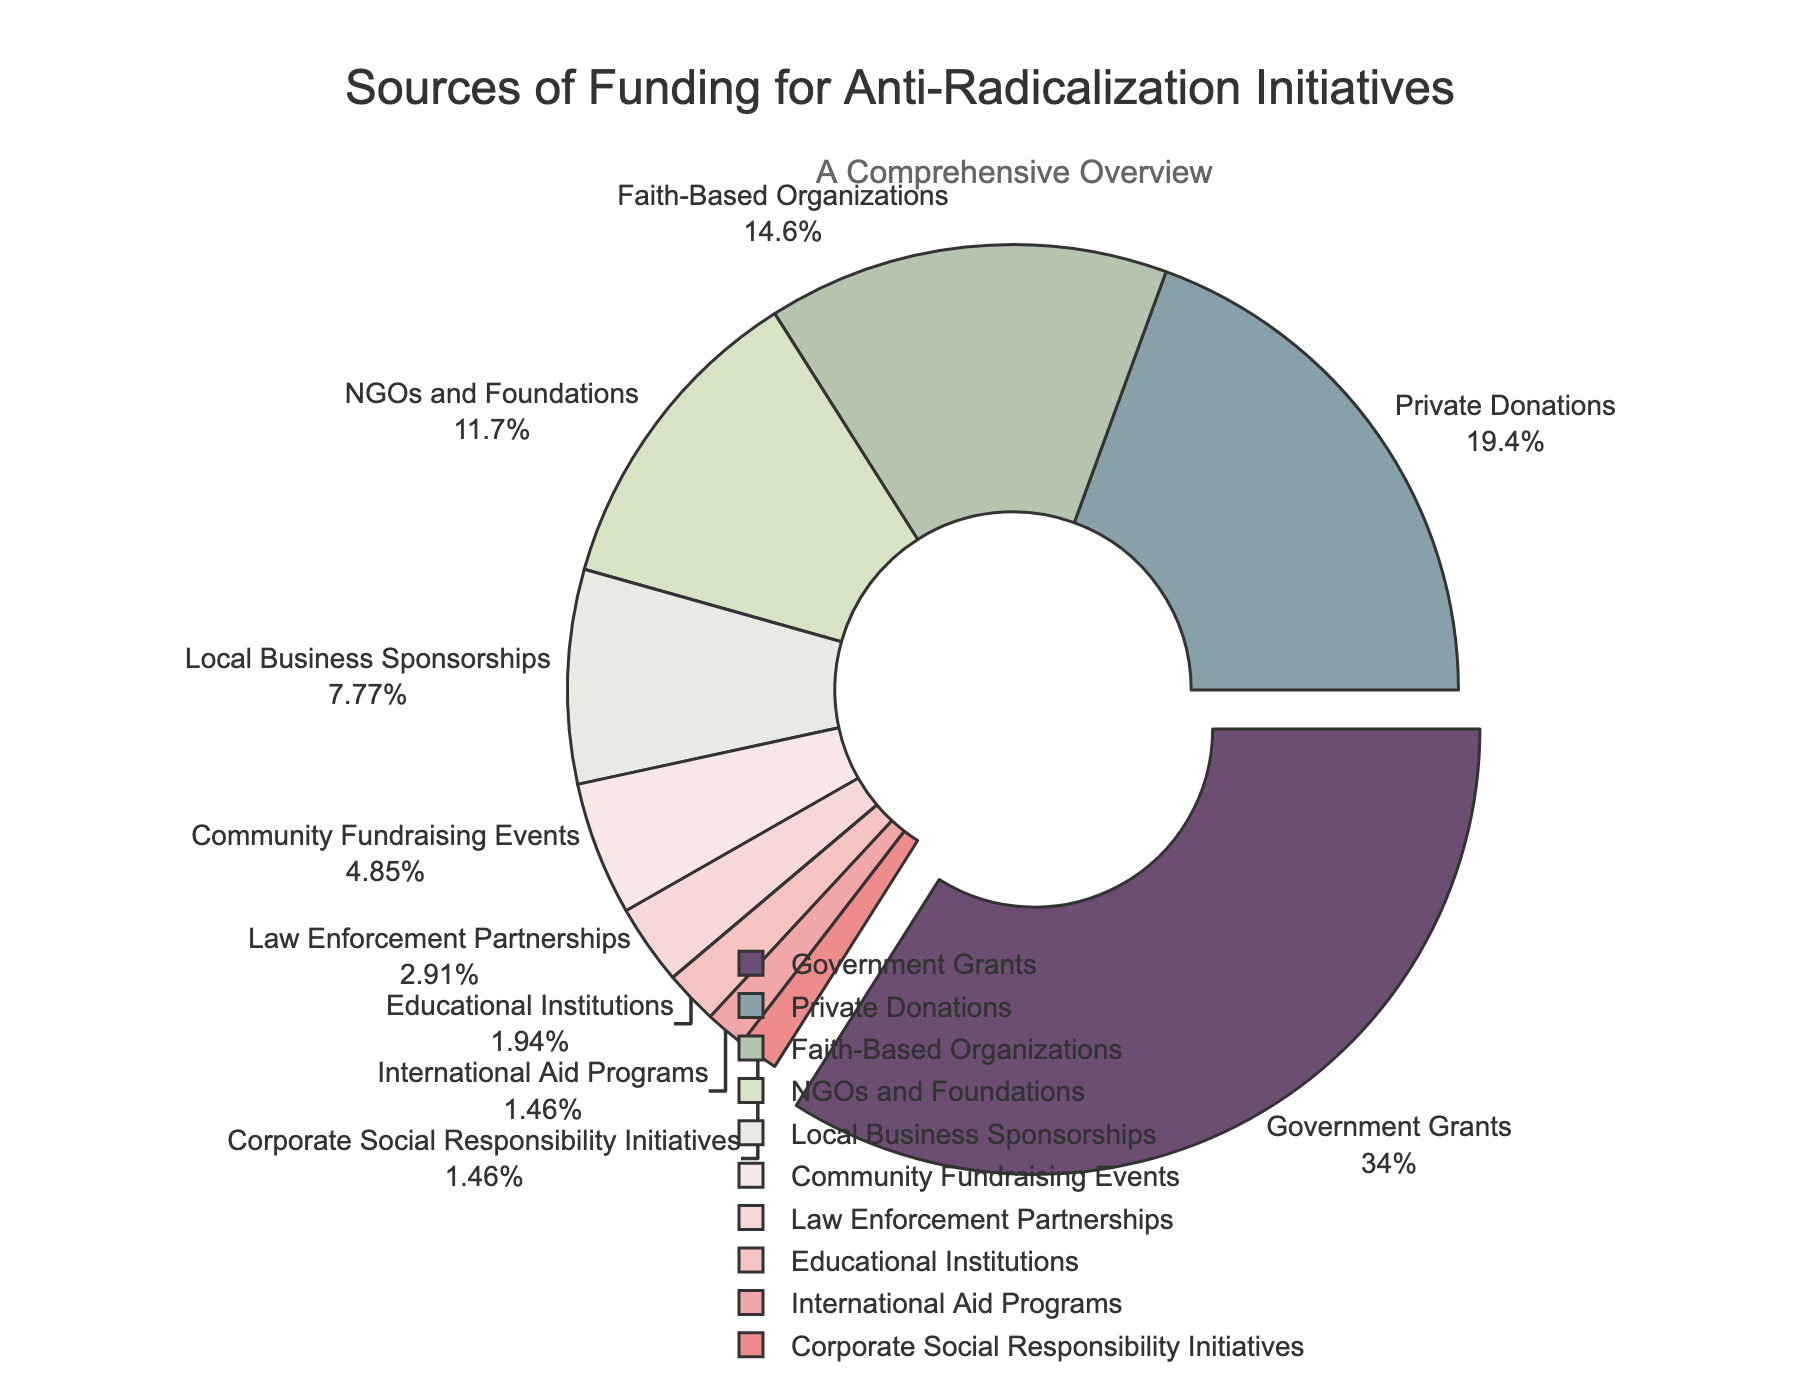What's the largest source of funding? The largest segment in the pie chart is labeled "Government Grants" which represents 35% of the total funding.
Answer: Government Grants Which source contributes less than 5% of the total funding? The segments labeled "Community Fundraising Events" (5%), "Law Enforcement Partnerships" (3%), "Educational Institutions" (2%), "International Aid Programs" (1.5%), and "Corporate Social Responsibility Initiatives" (1.5%) all contribute less than 5% of the total funding.
Answer: Community Fundraising Events, Law Enforcement Partnerships, Educational Institutions, International Aid Programs, Corporate Social Responsibility Initiatives How does the combined contribution of Private Donations and Faith-Based Organizations compare to Government Grants? Private Donations contribute 20% and Faith-Based Organizations contribute 15%. Their combined contribution is 20% + 15% = 35%, which is equal to the contribution from Government Grants (35%).
Answer: Equal What is the total contribution of sources that provide more than 10% of the funding? The sources providing more than 10% are Government Grants (35%), Private Donations (20%), and Faith-Based Organizations (15%). Their total contribution is 35% + 20% + 15% = 70%.
Answer: 70% What percentage of funding comes from local sources (consider local businesses and community fundraising)? Local Business Sponsorships contribute 8% and Community Fundraising Events contribute 5%. Their combined contribution is 8% + 5% = 13%.
Answer: 13% Which source has the same percentage contribution as International Aid Programs? The segments labeled "International Aid Programs" (1.5%) and "Corporate Social Responsibility Initiatives" (1.5%) both contribute the same percentage.
Answer: Corporate Social Responsibility Initiatives Which visual attribute distinguishes the largest segment in the pie chart? The largest segment, representing Government Grants, is visually distinguished by being slightly pulled away from the center of the pie chart.
Answer: Pulled away Compare the combined contribution of NGOs and Foundations with Educational Institutions. NGOs and Foundations contribute 12% and Educational Institutions contribute 2%. The combined contribution of NGOs and Foundations is higher at 12% compared to Educational Institutions' 2%.
Answer: Higher If Law Enforcement Partnerships and Educational Institutions doubled their contributions, what would be their new combined percentage? Current contributions are Law Enforcement Partnerships (3%) and Educational Institutions (2%). Doubling their contributions gives Law Enforcement Partnerships 3% x 2 = 6% and Educational Institutions 2% x 2 = 4%. Their new combined percentage would be 6% + 4% = 10%.
Answer: 10% 